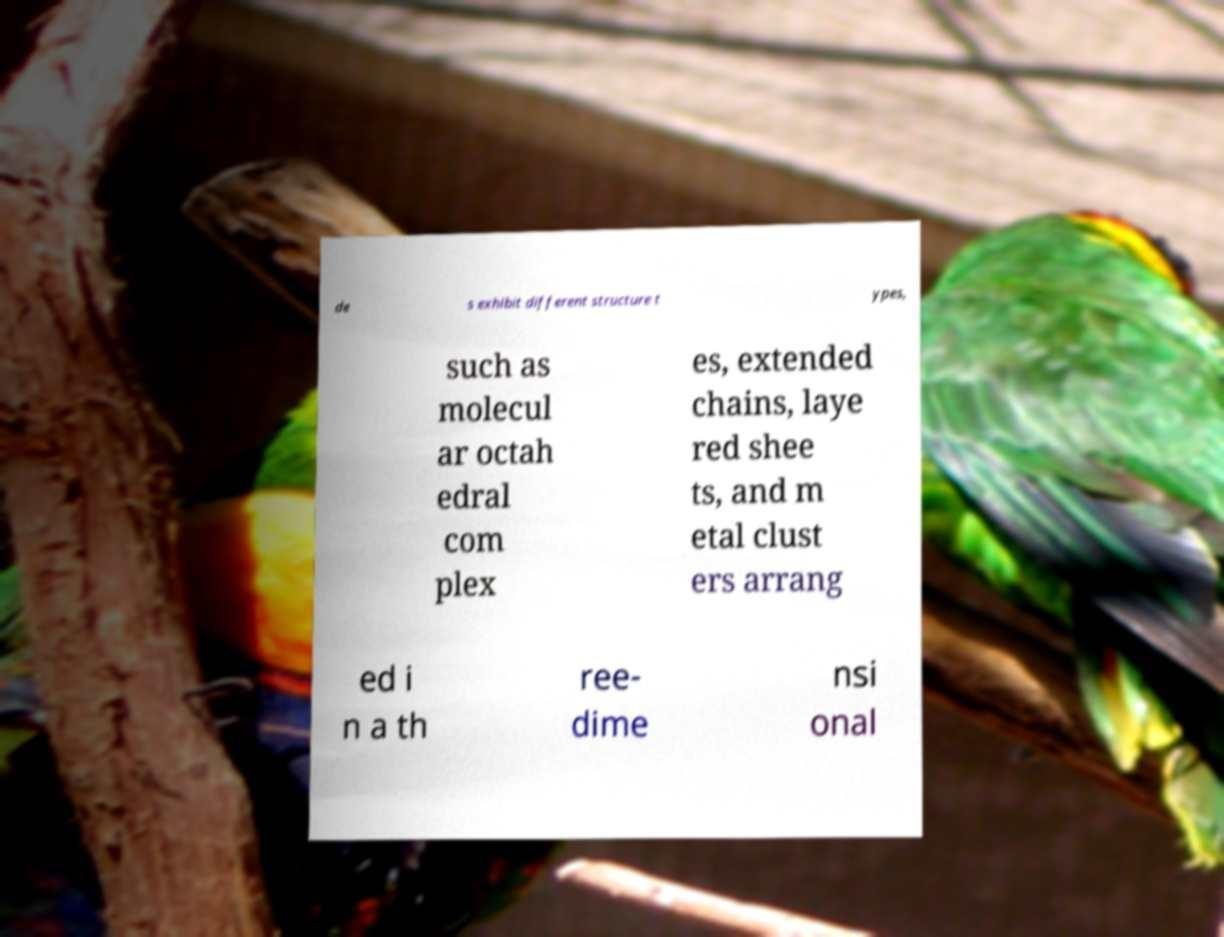There's text embedded in this image that I need extracted. Can you transcribe it verbatim? de s exhibit different structure t ypes, such as molecul ar octah edral com plex es, extended chains, laye red shee ts, and m etal clust ers arrang ed i n a th ree- dime nsi onal 